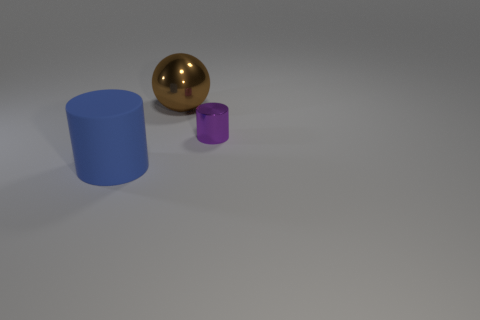What is the lighting like in this scene? The lighting in the scene seems to be diffused, with soft shadows hinting at a light source located above the objects, potentially simulating an overcast sky or indoor lighting without harsh direct light. 